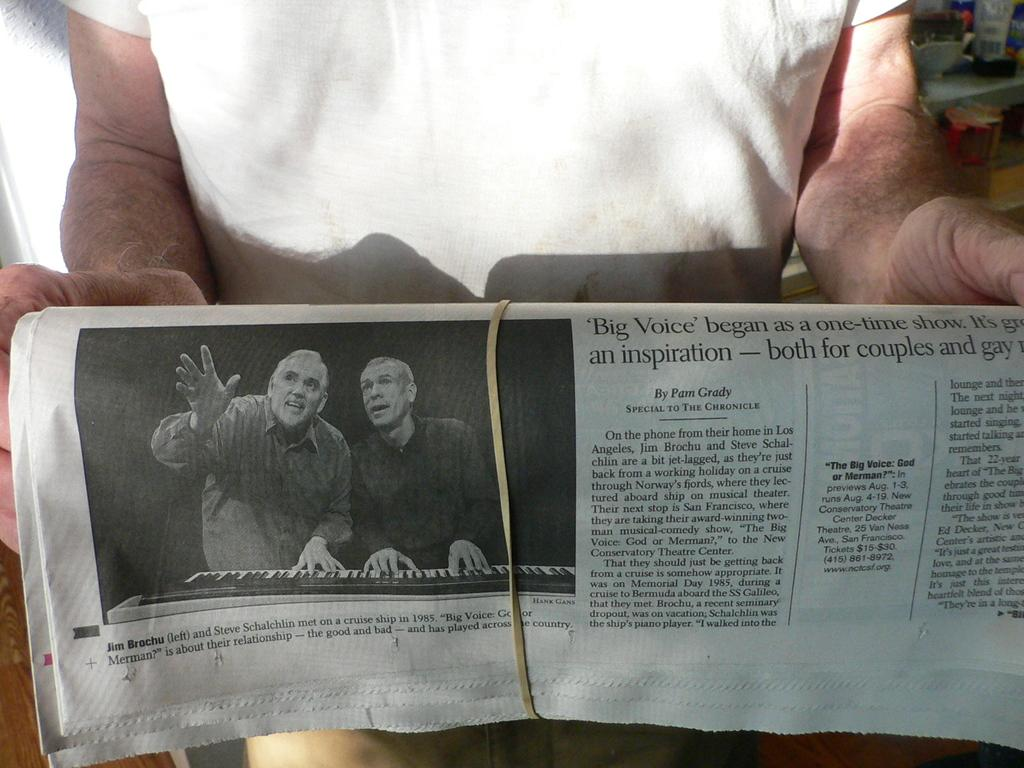<image>
Present a compact description of the photo's key features. A newspaper shows an article written by Pam Grady. 